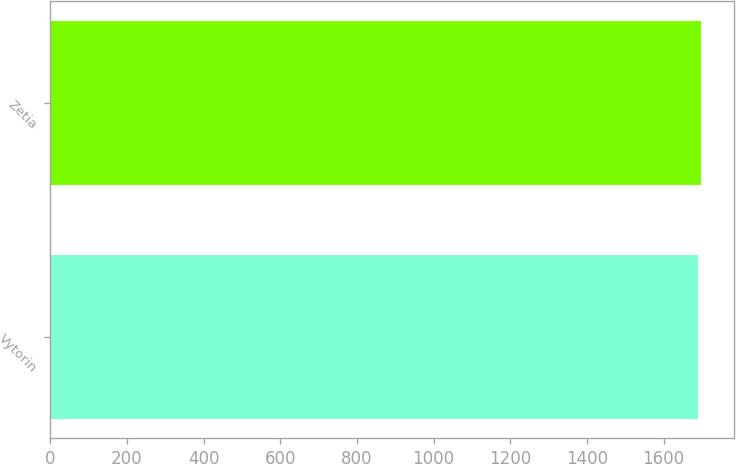Convert chart. <chart><loc_0><loc_0><loc_500><loc_500><bar_chart><fcel>Vytorin<fcel>Zetia<nl><fcel>1689<fcel>1698<nl></chart> 